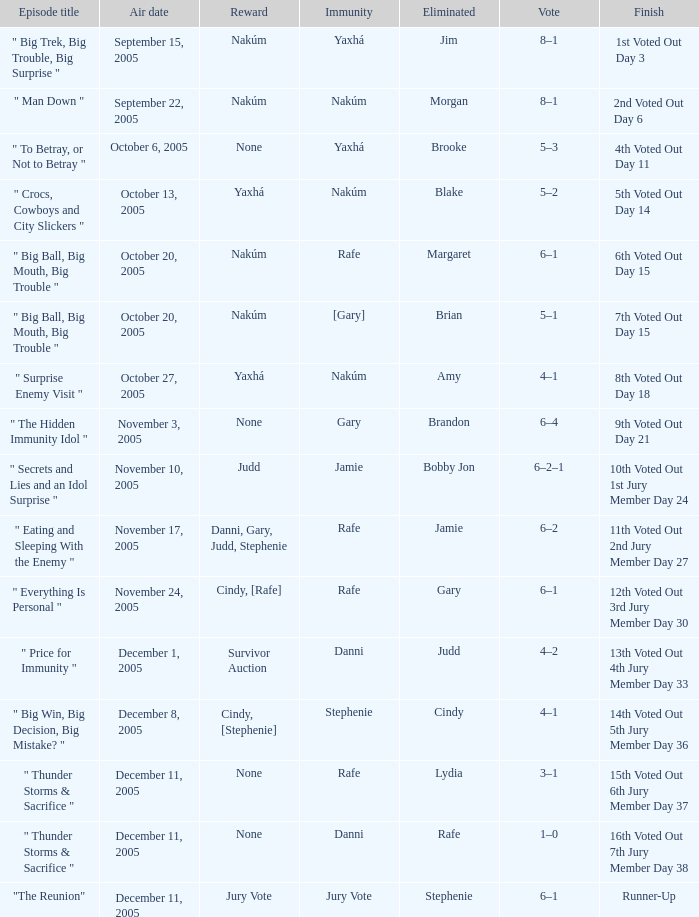How many rewards are there for air date October 6, 2005? None. 